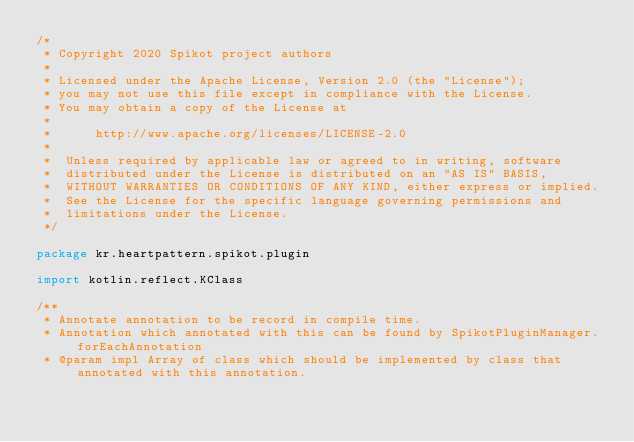<code> <loc_0><loc_0><loc_500><loc_500><_Kotlin_>/*
 * Copyright 2020 Spikot project authors
 *
 * Licensed under the Apache License, Version 2.0 (the "License");
 * you may not use this file except in compliance with the License.
 * You may obtain a copy of the License at
 *
 *      http://www.apache.org/licenses/LICENSE-2.0
 *
 *  Unless required by applicable law or agreed to in writing, software
 *  distributed under the License is distributed on an "AS IS" BASIS,
 *  WITHOUT WARRANTIES OR CONDITIONS OF ANY KIND, either express or implied.
 *  See the License for the specific language governing permissions and
 *  limitations under the License.
 */

package kr.heartpattern.spikot.plugin

import kotlin.reflect.KClass

/**
 * Annotate annotation to be record in compile time.
 * Annotation which annotated with this can be found by SpikotPluginManager.forEachAnnotation
 * @param impl Array of class which should be implemented by class that annotated with this annotation.</code> 